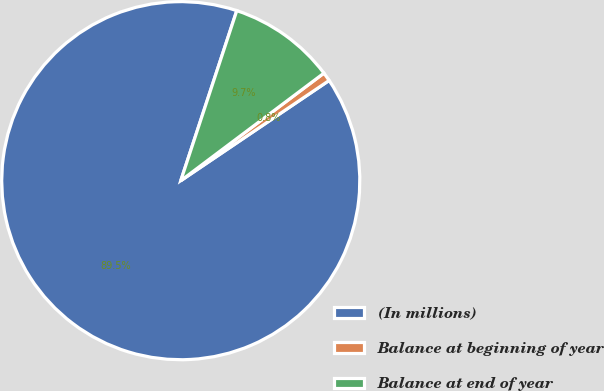<chart> <loc_0><loc_0><loc_500><loc_500><pie_chart><fcel>(In millions)<fcel>Balance at beginning of year<fcel>Balance at end of year<nl><fcel>89.52%<fcel>0.8%<fcel>9.68%<nl></chart> 